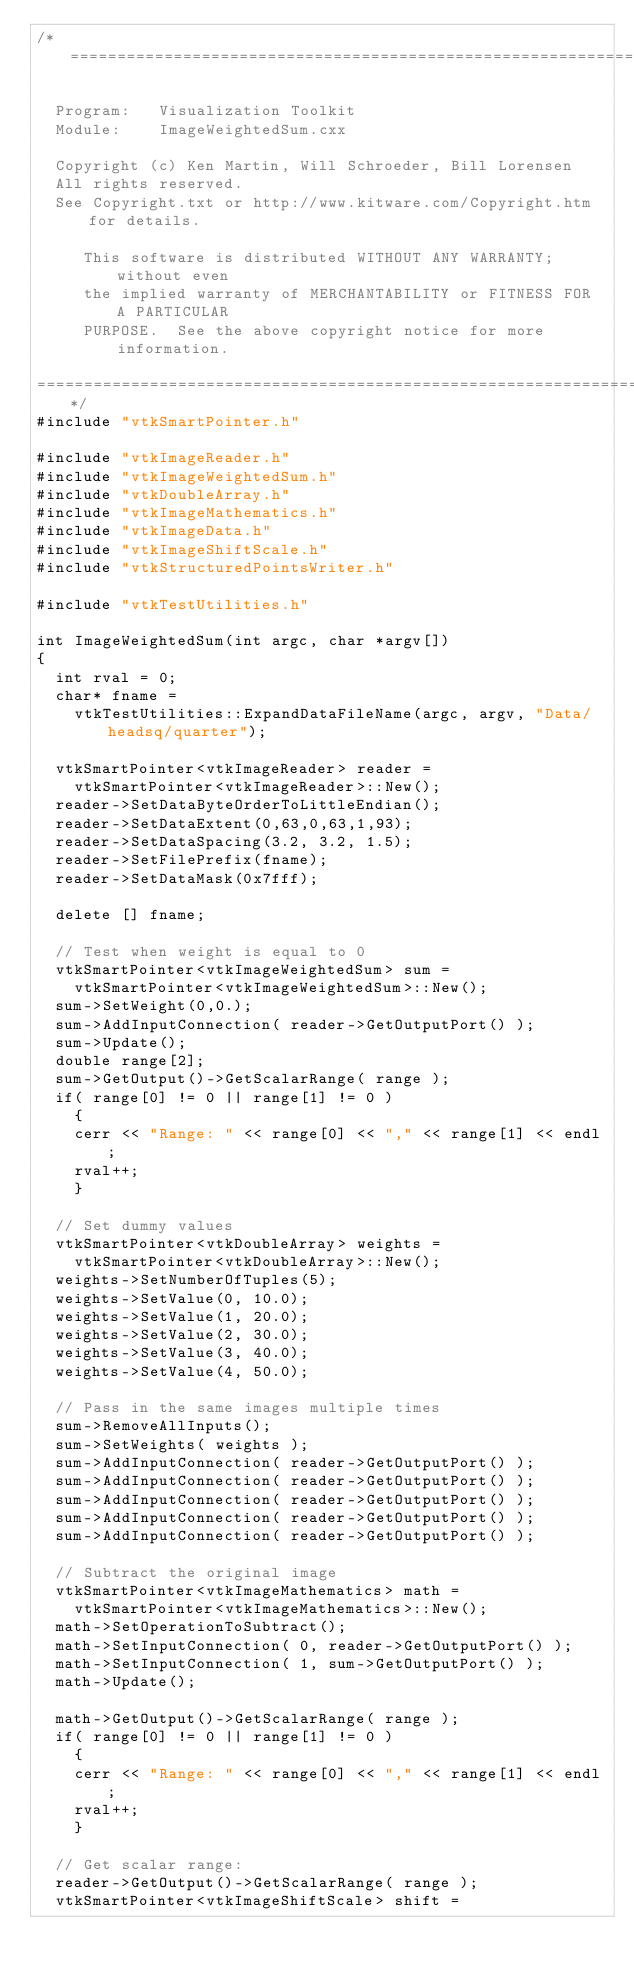Convert code to text. <code><loc_0><loc_0><loc_500><loc_500><_C++_>/*=========================================================================

  Program:   Visualization Toolkit
  Module:    ImageWeightedSum.cxx

  Copyright (c) Ken Martin, Will Schroeder, Bill Lorensen
  All rights reserved.
  See Copyright.txt or http://www.kitware.com/Copyright.htm for details.

     This software is distributed WITHOUT ANY WARRANTY; without even
     the implied warranty of MERCHANTABILITY or FITNESS FOR A PARTICULAR
     PURPOSE.  See the above copyright notice for more information.

=========================================================================*/
#include "vtkSmartPointer.h"

#include "vtkImageReader.h"
#include "vtkImageWeightedSum.h"
#include "vtkDoubleArray.h"
#include "vtkImageMathematics.h"
#include "vtkImageData.h"
#include "vtkImageShiftScale.h"
#include "vtkStructuredPointsWriter.h"

#include "vtkTestUtilities.h"

int ImageWeightedSum(int argc, char *argv[])
{
  int rval = 0;
  char* fname =
    vtkTestUtilities::ExpandDataFileName(argc, argv, "Data/headsq/quarter");

  vtkSmartPointer<vtkImageReader> reader =
    vtkSmartPointer<vtkImageReader>::New();
  reader->SetDataByteOrderToLittleEndian();
  reader->SetDataExtent(0,63,0,63,1,93);
  reader->SetDataSpacing(3.2, 3.2, 1.5);
  reader->SetFilePrefix(fname);
  reader->SetDataMask(0x7fff);

  delete [] fname;

  // Test when weight is equal to 0
  vtkSmartPointer<vtkImageWeightedSum> sum =
    vtkSmartPointer<vtkImageWeightedSum>::New();
  sum->SetWeight(0,0.);
  sum->AddInputConnection( reader->GetOutputPort() );
  sum->Update();
  double range[2];
  sum->GetOutput()->GetScalarRange( range );
  if( range[0] != 0 || range[1] != 0 )
    {
    cerr << "Range: " << range[0] << "," << range[1] << endl;
    rval++;
    }

  // Set dummy values
  vtkSmartPointer<vtkDoubleArray> weights =
    vtkSmartPointer<vtkDoubleArray>::New();
  weights->SetNumberOfTuples(5);
  weights->SetValue(0, 10.0);
  weights->SetValue(1, 20.0);
  weights->SetValue(2, 30.0);
  weights->SetValue(3, 40.0);
  weights->SetValue(4, 50.0);

  // Pass in the same images multiple times
  sum->RemoveAllInputs();
  sum->SetWeights( weights );
  sum->AddInputConnection( reader->GetOutputPort() );
  sum->AddInputConnection( reader->GetOutputPort() );
  sum->AddInputConnection( reader->GetOutputPort() );
  sum->AddInputConnection( reader->GetOutputPort() );
  sum->AddInputConnection( reader->GetOutputPort() );

  // Subtract the original image
  vtkSmartPointer<vtkImageMathematics> math =
    vtkSmartPointer<vtkImageMathematics>::New();
  math->SetOperationToSubtract();
  math->SetInputConnection( 0, reader->GetOutputPort() );
  math->SetInputConnection( 1, sum->GetOutputPort() );
  math->Update();

  math->GetOutput()->GetScalarRange( range );
  if( range[0] != 0 || range[1] != 0 )
    {
    cerr << "Range: " << range[0] << "," << range[1] << endl;
    rval++;
    }

  // Get scalar range:
  reader->GetOutput()->GetScalarRange( range );
  vtkSmartPointer<vtkImageShiftScale> shift =</code> 